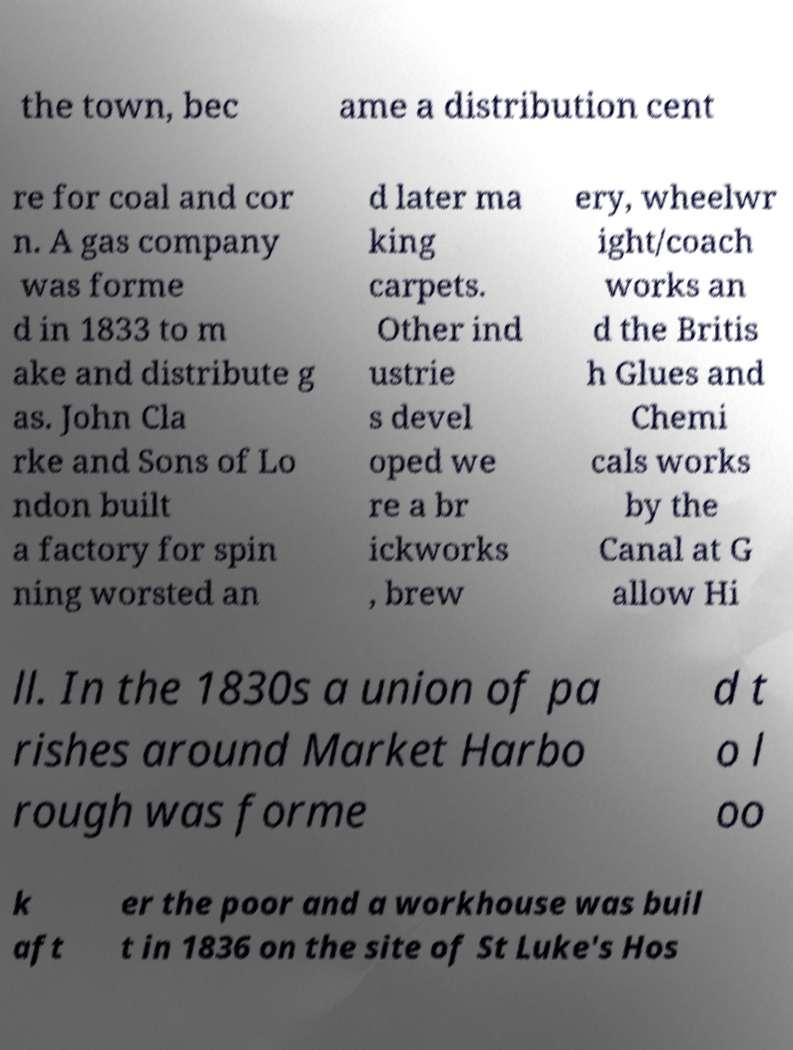Can you read and provide the text displayed in the image?This photo seems to have some interesting text. Can you extract and type it out for me? the town, bec ame a distribution cent re for coal and cor n. A gas company was forme d in 1833 to m ake and distribute g as. John Cla rke and Sons of Lo ndon built a factory for spin ning worsted an d later ma king carpets. Other ind ustrie s devel oped we re a br ickworks , brew ery, wheelwr ight/coach works an d the Britis h Glues and Chemi cals works by the Canal at G allow Hi ll. In the 1830s a union of pa rishes around Market Harbo rough was forme d t o l oo k aft er the poor and a workhouse was buil t in 1836 on the site of St Luke's Hos 